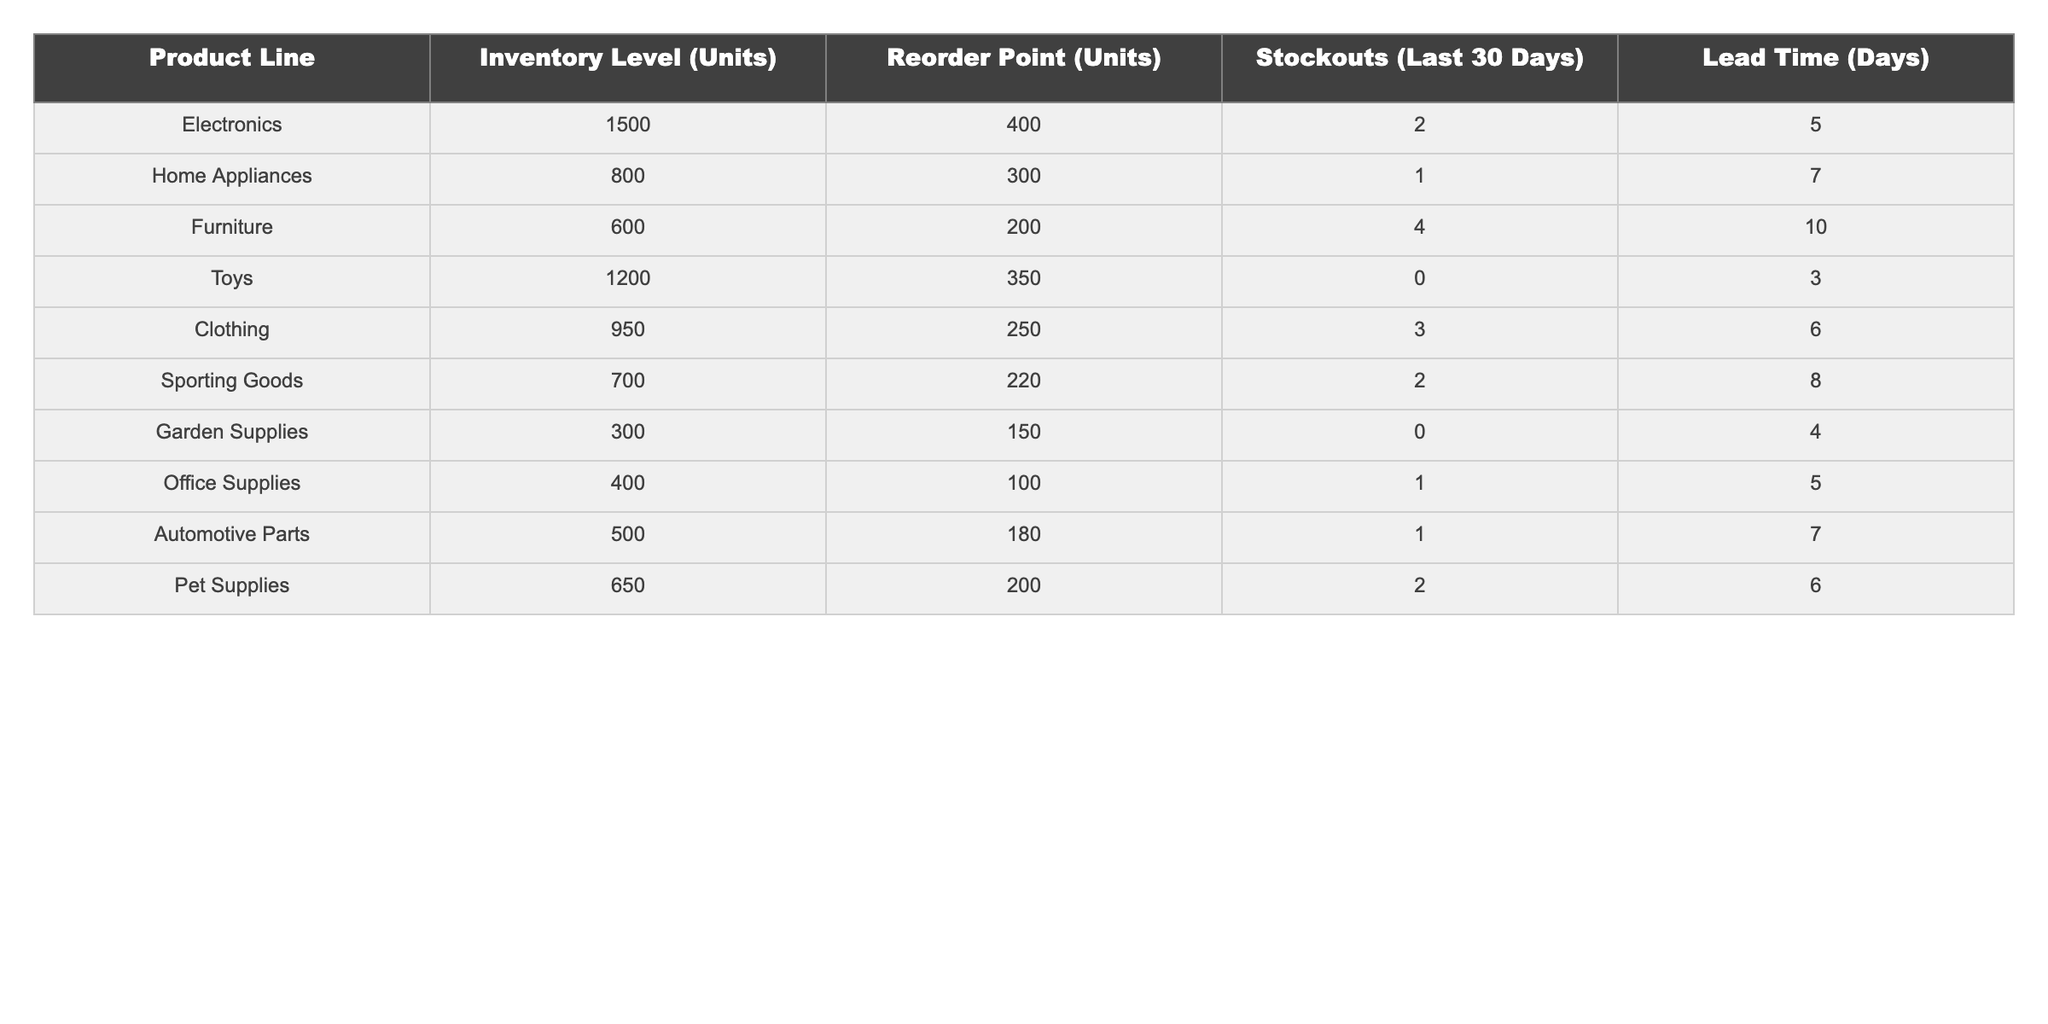What is the inventory level of Electronics? The table lists the inventory level of Electronics as 1500 units.
Answer: 1500 How many stockouts did the Furniture product line experience in the last 30 days? According to the table, Furniture had 4 stockouts in the last 30 days.
Answer: 4 What is the reorder point for Home Appliances? The reorder point for Home Appliances is 300 units, as indicated in the table.
Answer: 300 Which product line has the highest number of stockouts? By comparing the stockout numbers, Furniture has the highest with 4 stockouts.
Answer: Furniture What is the total number of stockouts across all product lines? To find the total, we add the stockouts: 2 + 1 + 4 + 0 + 3 + 2 + 0 + 1 + 1 + 2 = 16.
Answer: 16 How many days is the lead time for Pet Supplies? The lead time for Pet Supplies is listed as 6 days in the table.
Answer: 6 Is there any product line with zero stockouts? Yes, both Toys and Garden Supplies have zero stockouts in the last 30 days.
Answer: Yes Which product line has the lowest inventory level? By examining the inventory levels, Garden Supplies at 300 units has the lowest.
Answer: Garden Supplies What is the average inventory level across all product lines? The total inventory is 1500 + 800 + 600 + 1200 + 950 + 700 + 300 + 400 + 500 + 650 = 6100 units. There are 10 product lines, so the average is 6100/10 = 610.
Answer: 610 If the lead time for Clothing increased by 2 days, what would the new lead time be? The current lead time for Clothing is 6 days. Adding 2 days gives 6 + 2 = 8 days.
Answer: 8 